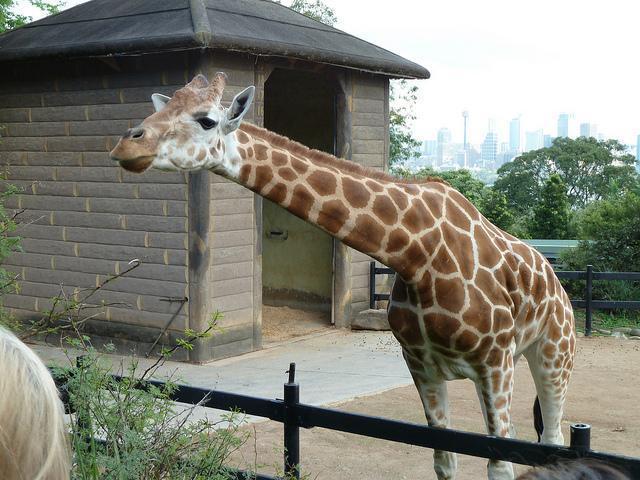How many elephant are in the photo?
Give a very brief answer. 0. 